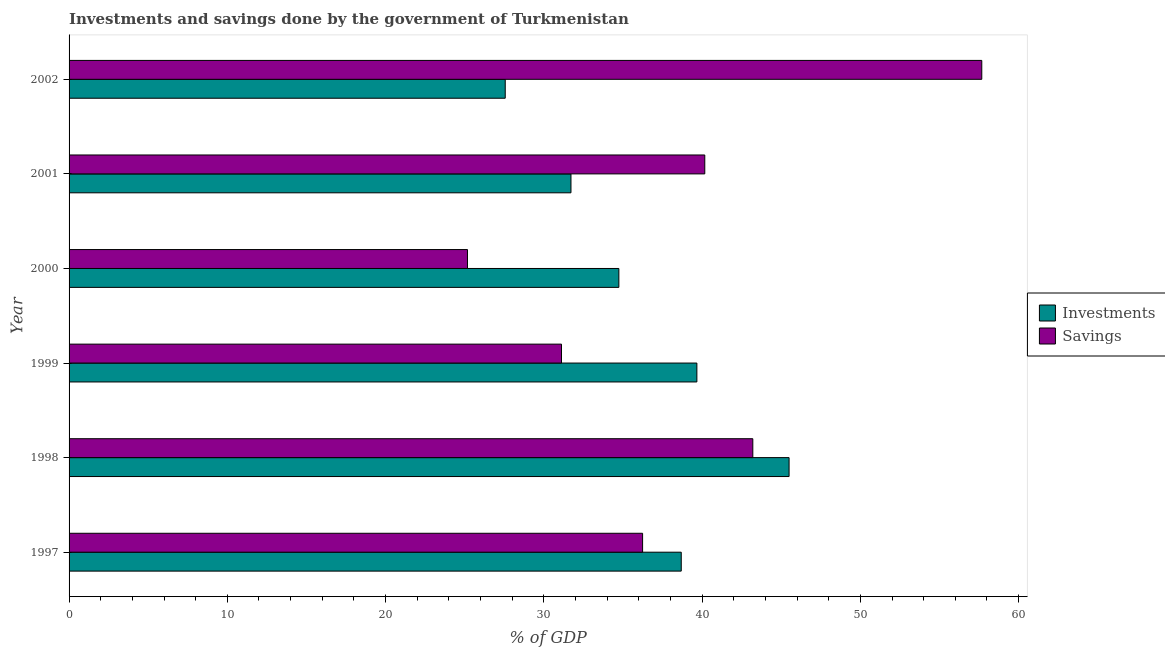How many groups of bars are there?
Your response must be concise. 6. Are the number of bars per tick equal to the number of legend labels?
Offer a terse response. Yes. Are the number of bars on each tick of the Y-axis equal?
Your answer should be compact. Yes. What is the label of the 3rd group of bars from the top?
Ensure brevity in your answer.  2000. In how many cases, is the number of bars for a given year not equal to the number of legend labels?
Keep it short and to the point. 0. What is the investments of government in 1998?
Offer a terse response. 45.49. Across all years, what is the maximum savings of government?
Provide a succinct answer. 57.67. Across all years, what is the minimum investments of government?
Provide a short and direct response. 27.56. In which year was the investments of government maximum?
Give a very brief answer. 1998. What is the total savings of government in the graph?
Offer a terse response. 233.57. What is the difference between the savings of government in 1997 and that in 1999?
Offer a very short reply. 5.12. What is the difference between the investments of government in 1998 and the savings of government in 1997?
Give a very brief answer. 9.26. What is the average savings of government per year?
Your response must be concise. 38.93. In the year 2001, what is the difference between the savings of government and investments of government?
Offer a terse response. 8.46. What is the ratio of the investments of government in 1997 to that in 2002?
Your answer should be compact. 1.4. Is the savings of government in 1997 less than that in 1998?
Make the answer very short. Yes. What is the difference between the highest and the second highest investments of government?
Your answer should be very brief. 5.83. What is the difference between the highest and the lowest investments of government?
Give a very brief answer. 17.94. What does the 1st bar from the top in 1997 represents?
Your answer should be compact. Savings. What does the 2nd bar from the bottom in 2000 represents?
Your answer should be compact. Savings. Are all the bars in the graph horizontal?
Your response must be concise. Yes. How many years are there in the graph?
Provide a short and direct response. 6. Where does the legend appear in the graph?
Your response must be concise. Center right. What is the title of the graph?
Offer a terse response. Investments and savings done by the government of Turkmenistan. What is the label or title of the X-axis?
Offer a terse response. % of GDP. What is the % of GDP in Investments in 1997?
Make the answer very short. 38.68. What is the % of GDP in Savings in 1997?
Offer a terse response. 36.24. What is the % of GDP in Investments in 1998?
Your response must be concise. 45.49. What is the % of GDP in Savings in 1998?
Ensure brevity in your answer.  43.2. What is the % of GDP of Investments in 1999?
Your answer should be very brief. 39.67. What is the % of GDP in Savings in 1999?
Keep it short and to the point. 31.12. What is the % of GDP of Investments in 2000?
Offer a terse response. 34.74. What is the % of GDP in Savings in 2000?
Offer a very short reply. 25.17. What is the % of GDP in Investments in 2001?
Keep it short and to the point. 31.71. What is the % of GDP of Savings in 2001?
Your answer should be very brief. 40.17. What is the % of GDP in Investments in 2002?
Provide a succinct answer. 27.56. What is the % of GDP in Savings in 2002?
Ensure brevity in your answer.  57.67. Across all years, what is the maximum % of GDP in Investments?
Your answer should be very brief. 45.49. Across all years, what is the maximum % of GDP of Savings?
Provide a short and direct response. 57.67. Across all years, what is the minimum % of GDP of Investments?
Your answer should be very brief. 27.56. Across all years, what is the minimum % of GDP of Savings?
Provide a short and direct response. 25.17. What is the total % of GDP of Investments in the graph?
Provide a succinct answer. 217.86. What is the total % of GDP of Savings in the graph?
Make the answer very short. 233.57. What is the difference between the % of GDP in Investments in 1997 and that in 1998?
Offer a terse response. -6.81. What is the difference between the % of GDP of Savings in 1997 and that in 1998?
Ensure brevity in your answer.  -6.96. What is the difference between the % of GDP of Investments in 1997 and that in 1999?
Your response must be concise. -0.99. What is the difference between the % of GDP of Savings in 1997 and that in 1999?
Offer a very short reply. 5.12. What is the difference between the % of GDP in Investments in 1997 and that in 2000?
Offer a very short reply. 3.94. What is the difference between the % of GDP in Savings in 1997 and that in 2000?
Provide a succinct answer. 11.07. What is the difference between the % of GDP of Investments in 1997 and that in 2001?
Offer a very short reply. 6.97. What is the difference between the % of GDP in Savings in 1997 and that in 2001?
Give a very brief answer. -3.93. What is the difference between the % of GDP of Investments in 1997 and that in 2002?
Offer a very short reply. 11.12. What is the difference between the % of GDP in Savings in 1997 and that in 2002?
Provide a succinct answer. -21.43. What is the difference between the % of GDP in Investments in 1998 and that in 1999?
Make the answer very short. 5.83. What is the difference between the % of GDP in Savings in 1998 and that in 1999?
Ensure brevity in your answer.  12.09. What is the difference between the % of GDP in Investments in 1998 and that in 2000?
Keep it short and to the point. 10.76. What is the difference between the % of GDP of Savings in 1998 and that in 2000?
Provide a succinct answer. 18.03. What is the difference between the % of GDP of Investments in 1998 and that in 2001?
Ensure brevity in your answer.  13.78. What is the difference between the % of GDP of Savings in 1998 and that in 2001?
Provide a short and direct response. 3.03. What is the difference between the % of GDP in Investments in 1998 and that in 2002?
Give a very brief answer. 17.94. What is the difference between the % of GDP in Savings in 1998 and that in 2002?
Offer a very short reply. -14.47. What is the difference between the % of GDP of Investments in 1999 and that in 2000?
Offer a terse response. 4.93. What is the difference between the % of GDP of Savings in 1999 and that in 2000?
Provide a short and direct response. 5.94. What is the difference between the % of GDP in Investments in 1999 and that in 2001?
Your answer should be very brief. 7.96. What is the difference between the % of GDP in Savings in 1999 and that in 2001?
Offer a very short reply. -9.05. What is the difference between the % of GDP in Investments in 1999 and that in 2002?
Keep it short and to the point. 12.11. What is the difference between the % of GDP of Savings in 1999 and that in 2002?
Ensure brevity in your answer.  -26.56. What is the difference between the % of GDP in Investments in 2000 and that in 2001?
Your answer should be very brief. 3.03. What is the difference between the % of GDP in Savings in 2000 and that in 2001?
Make the answer very short. -14.99. What is the difference between the % of GDP of Investments in 2000 and that in 2002?
Your response must be concise. 7.18. What is the difference between the % of GDP of Savings in 2000 and that in 2002?
Offer a terse response. -32.5. What is the difference between the % of GDP of Investments in 2001 and that in 2002?
Keep it short and to the point. 4.15. What is the difference between the % of GDP in Savings in 2001 and that in 2002?
Ensure brevity in your answer.  -17.5. What is the difference between the % of GDP in Investments in 1997 and the % of GDP in Savings in 1998?
Make the answer very short. -4.52. What is the difference between the % of GDP in Investments in 1997 and the % of GDP in Savings in 1999?
Offer a terse response. 7.57. What is the difference between the % of GDP in Investments in 1997 and the % of GDP in Savings in 2000?
Make the answer very short. 13.51. What is the difference between the % of GDP in Investments in 1997 and the % of GDP in Savings in 2001?
Give a very brief answer. -1.49. What is the difference between the % of GDP in Investments in 1997 and the % of GDP in Savings in 2002?
Make the answer very short. -18.99. What is the difference between the % of GDP in Investments in 1998 and the % of GDP in Savings in 1999?
Offer a terse response. 14.38. What is the difference between the % of GDP in Investments in 1998 and the % of GDP in Savings in 2000?
Ensure brevity in your answer.  20.32. What is the difference between the % of GDP in Investments in 1998 and the % of GDP in Savings in 2001?
Give a very brief answer. 5.33. What is the difference between the % of GDP in Investments in 1998 and the % of GDP in Savings in 2002?
Your answer should be very brief. -12.18. What is the difference between the % of GDP of Investments in 1999 and the % of GDP of Savings in 2000?
Your answer should be compact. 14.49. What is the difference between the % of GDP in Investments in 1999 and the % of GDP in Savings in 2001?
Your response must be concise. -0.5. What is the difference between the % of GDP of Investments in 1999 and the % of GDP of Savings in 2002?
Your response must be concise. -18. What is the difference between the % of GDP of Investments in 2000 and the % of GDP of Savings in 2001?
Ensure brevity in your answer.  -5.43. What is the difference between the % of GDP in Investments in 2000 and the % of GDP in Savings in 2002?
Keep it short and to the point. -22.93. What is the difference between the % of GDP of Investments in 2001 and the % of GDP of Savings in 2002?
Provide a short and direct response. -25.96. What is the average % of GDP of Investments per year?
Your answer should be very brief. 36.31. What is the average % of GDP of Savings per year?
Ensure brevity in your answer.  38.93. In the year 1997, what is the difference between the % of GDP in Investments and % of GDP in Savings?
Provide a succinct answer. 2.44. In the year 1998, what is the difference between the % of GDP in Investments and % of GDP in Savings?
Offer a very short reply. 2.29. In the year 1999, what is the difference between the % of GDP in Investments and % of GDP in Savings?
Your response must be concise. 8.55. In the year 2000, what is the difference between the % of GDP in Investments and % of GDP in Savings?
Offer a terse response. 9.56. In the year 2001, what is the difference between the % of GDP of Investments and % of GDP of Savings?
Offer a very short reply. -8.46. In the year 2002, what is the difference between the % of GDP of Investments and % of GDP of Savings?
Provide a succinct answer. -30.11. What is the ratio of the % of GDP in Investments in 1997 to that in 1998?
Your response must be concise. 0.85. What is the ratio of the % of GDP of Savings in 1997 to that in 1998?
Offer a very short reply. 0.84. What is the ratio of the % of GDP of Investments in 1997 to that in 1999?
Give a very brief answer. 0.98. What is the ratio of the % of GDP in Savings in 1997 to that in 1999?
Provide a succinct answer. 1.16. What is the ratio of the % of GDP in Investments in 1997 to that in 2000?
Your answer should be very brief. 1.11. What is the ratio of the % of GDP of Savings in 1997 to that in 2000?
Provide a succinct answer. 1.44. What is the ratio of the % of GDP of Investments in 1997 to that in 2001?
Give a very brief answer. 1.22. What is the ratio of the % of GDP of Savings in 1997 to that in 2001?
Provide a short and direct response. 0.9. What is the ratio of the % of GDP in Investments in 1997 to that in 2002?
Provide a short and direct response. 1.4. What is the ratio of the % of GDP of Savings in 1997 to that in 2002?
Provide a short and direct response. 0.63. What is the ratio of the % of GDP of Investments in 1998 to that in 1999?
Give a very brief answer. 1.15. What is the ratio of the % of GDP of Savings in 1998 to that in 1999?
Give a very brief answer. 1.39. What is the ratio of the % of GDP of Investments in 1998 to that in 2000?
Give a very brief answer. 1.31. What is the ratio of the % of GDP of Savings in 1998 to that in 2000?
Offer a very short reply. 1.72. What is the ratio of the % of GDP of Investments in 1998 to that in 2001?
Your answer should be compact. 1.43. What is the ratio of the % of GDP in Savings in 1998 to that in 2001?
Your answer should be very brief. 1.08. What is the ratio of the % of GDP of Investments in 1998 to that in 2002?
Give a very brief answer. 1.65. What is the ratio of the % of GDP of Savings in 1998 to that in 2002?
Provide a succinct answer. 0.75. What is the ratio of the % of GDP of Investments in 1999 to that in 2000?
Provide a succinct answer. 1.14. What is the ratio of the % of GDP of Savings in 1999 to that in 2000?
Make the answer very short. 1.24. What is the ratio of the % of GDP in Investments in 1999 to that in 2001?
Keep it short and to the point. 1.25. What is the ratio of the % of GDP in Savings in 1999 to that in 2001?
Provide a short and direct response. 0.77. What is the ratio of the % of GDP of Investments in 1999 to that in 2002?
Your answer should be compact. 1.44. What is the ratio of the % of GDP in Savings in 1999 to that in 2002?
Your answer should be very brief. 0.54. What is the ratio of the % of GDP in Investments in 2000 to that in 2001?
Give a very brief answer. 1.1. What is the ratio of the % of GDP in Savings in 2000 to that in 2001?
Offer a very short reply. 0.63. What is the ratio of the % of GDP of Investments in 2000 to that in 2002?
Provide a short and direct response. 1.26. What is the ratio of the % of GDP of Savings in 2000 to that in 2002?
Provide a succinct answer. 0.44. What is the ratio of the % of GDP of Investments in 2001 to that in 2002?
Your response must be concise. 1.15. What is the ratio of the % of GDP in Savings in 2001 to that in 2002?
Your answer should be compact. 0.7. What is the difference between the highest and the second highest % of GDP of Investments?
Your answer should be compact. 5.83. What is the difference between the highest and the second highest % of GDP in Savings?
Give a very brief answer. 14.47. What is the difference between the highest and the lowest % of GDP in Investments?
Your answer should be very brief. 17.94. What is the difference between the highest and the lowest % of GDP of Savings?
Give a very brief answer. 32.5. 